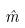<formula> <loc_0><loc_0><loc_500><loc_500>\hat { m }</formula> 